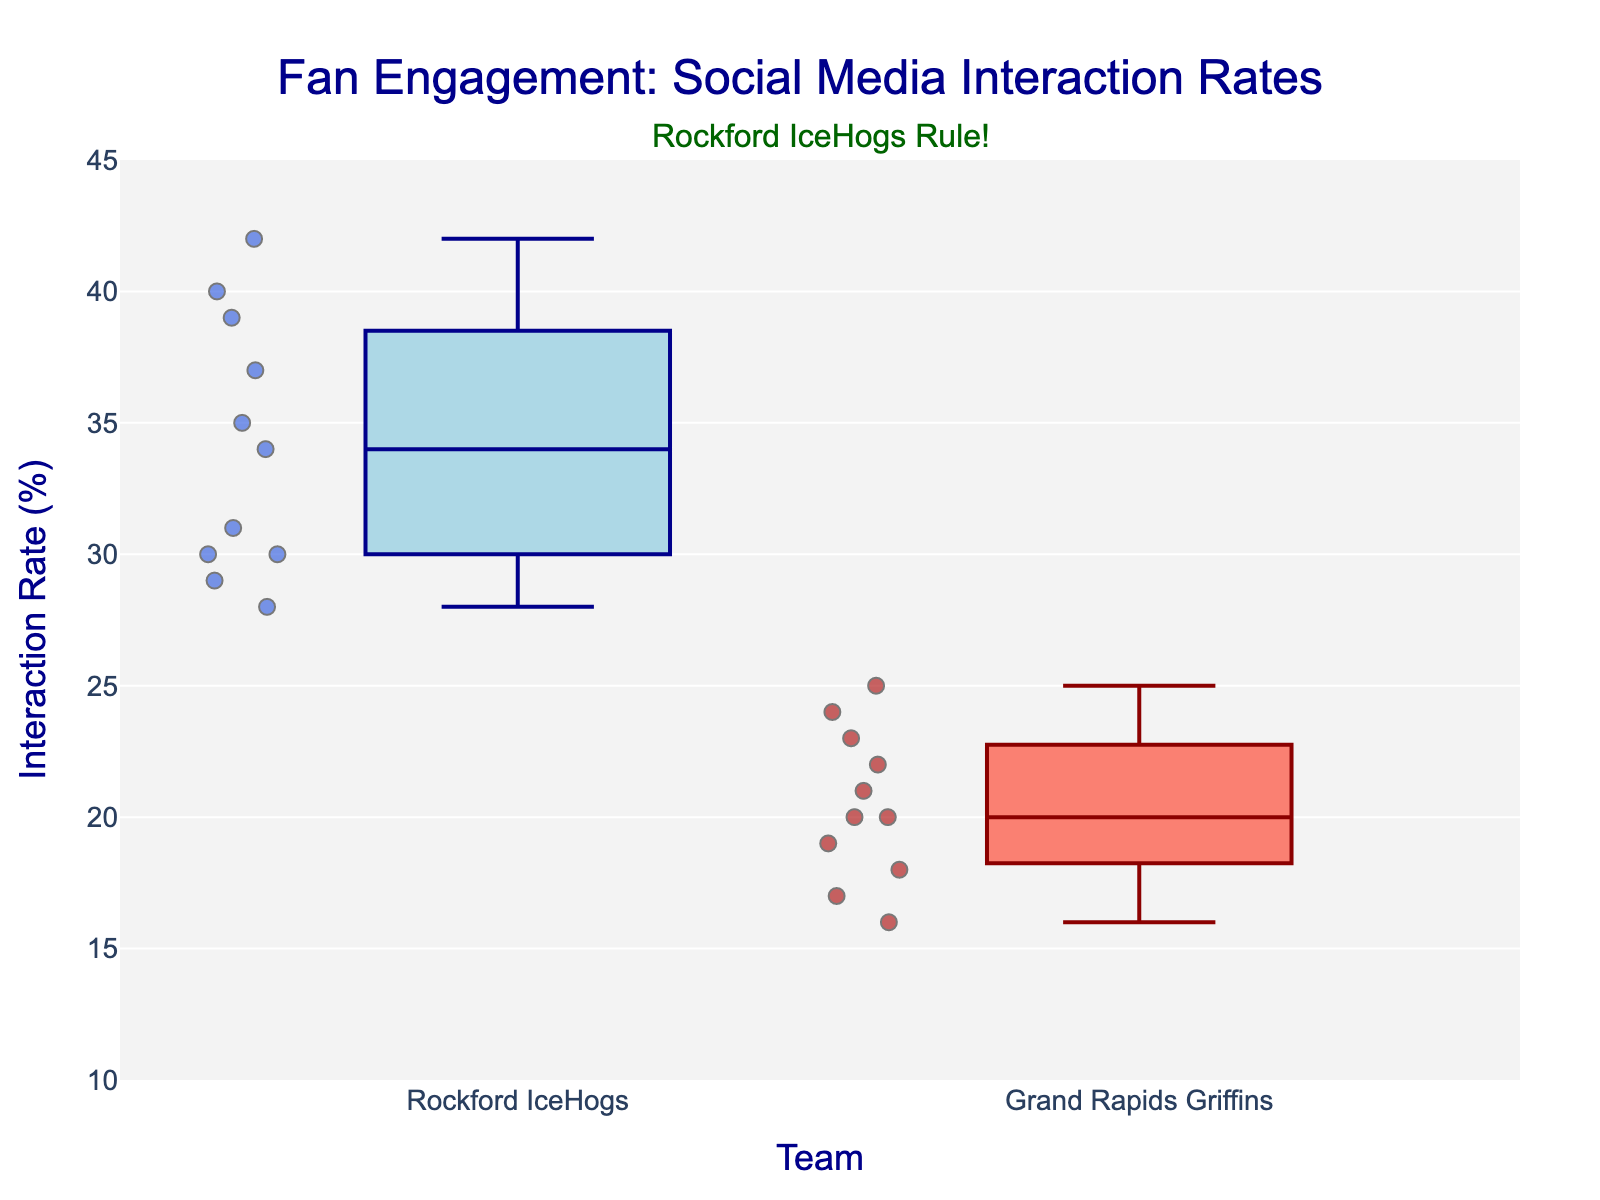How many Rockford IceHogs interaction rates are displayed? Count the number of data points (points) under the Rockford IceHogs category.
Answer: 11 What is the title of the plot? Look at the top center of the plot to read the text title.
Answer: Fan Engagement: Social Media Interaction Rates What is the median interaction rate for Rockford IceHogs fans? Locate the middle value for the Rockford IceHogs box, which is the line inside the box.
Answer: 34 What is the overall range of interaction rates for Grand Rapids Griffins fans? Identify the minimum and maximum values of the interaction rates for Grand Rapids Griffins and compute the difference. The min is 16, and the max is 25, so the range is 25 - 16.
Answer: 9 Which team has a higher number of data points? Compare the counts of data points (points) displayed under Rockford IceHogs and Grand Rapids Griffins categories.
Answer: Rockford IceHogs What is the interquartile range (IQR) for Rockford IceHogs fans? Determine the values at the first (Q1) and third quartiles (Q3) inside the Rockford IceHogs box. Then compute IQR by Q3 - Q1. If Q1 is 30 and Q3 is 38, then IQR is 38 - 30.
Answer: 8 Which team has a higher maximum interaction rate? Identify the maximum y-values for each team, and compare them.
Answer: Rockford IceHogs What annotation is displayed on the plot? Read the text written as the annotation besides the plot title.
Answer: Rockford IceHogs Rule! What is the color of the markers for Grand Rapids Griffins fans? Observe the color of the points for the Grand Rapids Griffins category.
Answer: Firebrick 